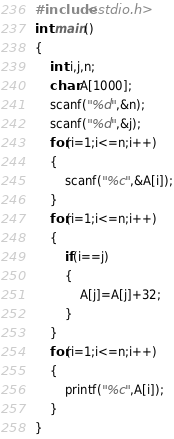Convert code to text. <code><loc_0><loc_0><loc_500><loc_500><_C_>#include<stdio.h>
int main()
{
	int i,j,n;
	char A[1000];
	scanf("%d",&n);
	scanf("%d",&j);
	for(i=1;i<=n;i++)
	{
		scanf("%c",&A[i]);
	}
	for(i=1;i<=n;i++)
	{
		if(i==j)
		{
			A[j]=A[j]+32;
		}
	}
	for(i=1;i<=n;i++)
	{
		printf("%c",A[i]);
	}
}</code> 